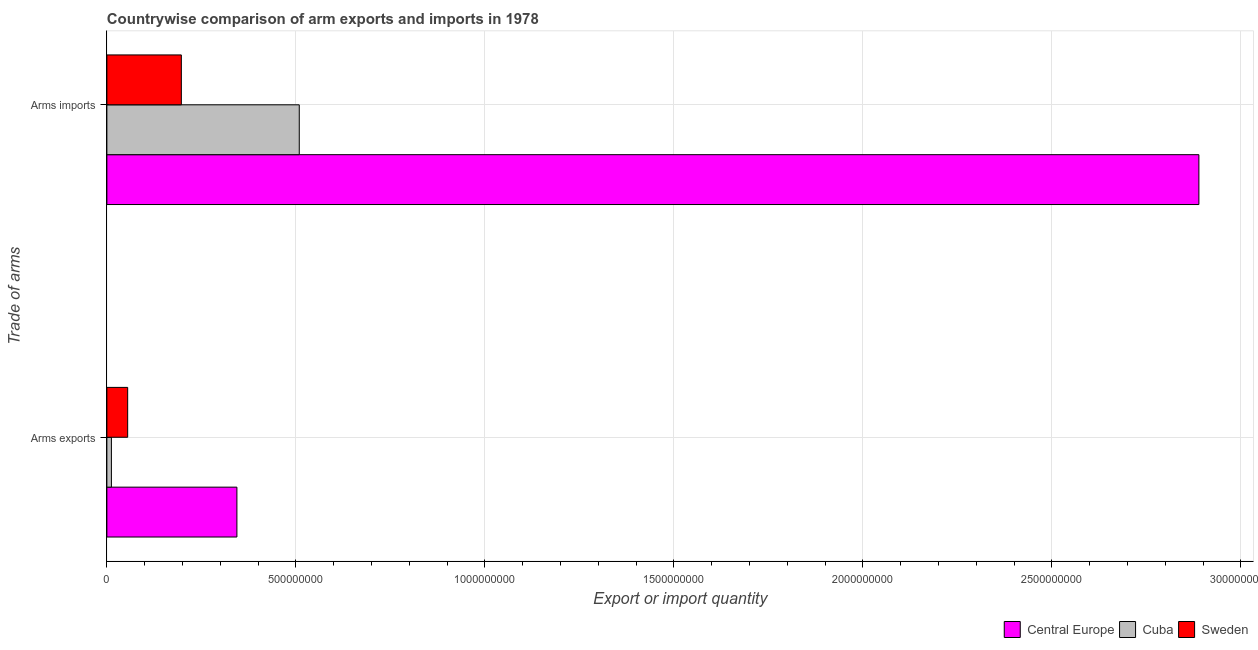How many bars are there on the 1st tick from the top?
Your answer should be compact. 3. What is the label of the 1st group of bars from the top?
Offer a very short reply. Arms imports. What is the arms imports in Cuba?
Your answer should be very brief. 5.09e+08. Across all countries, what is the maximum arms imports?
Your answer should be compact. 2.89e+09. Across all countries, what is the minimum arms exports?
Offer a terse response. 1.20e+07. In which country was the arms exports maximum?
Provide a short and direct response. Central Europe. What is the total arms exports in the graph?
Ensure brevity in your answer.  4.11e+08. What is the difference between the arms imports in Central Europe and that in Cuba?
Keep it short and to the point. 2.38e+09. What is the difference between the arms imports in Cuba and the arms exports in Central Europe?
Offer a very short reply. 1.65e+08. What is the average arms imports per country?
Give a very brief answer. 1.20e+09. What is the difference between the arms exports and arms imports in Sweden?
Give a very brief answer. -1.42e+08. In how many countries, is the arms exports greater than 100000000 ?
Your answer should be very brief. 1. What is the ratio of the arms imports in Sweden to that in Cuba?
Keep it short and to the point. 0.39. In how many countries, is the arms imports greater than the average arms imports taken over all countries?
Provide a succinct answer. 1. What does the 2nd bar from the top in Arms exports represents?
Make the answer very short. Cuba. What does the 2nd bar from the bottom in Arms exports represents?
Ensure brevity in your answer.  Cuba. How many bars are there?
Your answer should be compact. 6. Are all the bars in the graph horizontal?
Give a very brief answer. Yes. What is the difference between two consecutive major ticks on the X-axis?
Ensure brevity in your answer.  5.00e+08. Are the values on the major ticks of X-axis written in scientific E-notation?
Offer a terse response. No. Does the graph contain any zero values?
Your answer should be compact. No. Does the graph contain grids?
Make the answer very short. Yes. How are the legend labels stacked?
Give a very brief answer. Horizontal. What is the title of the graph?
Give a very brief answer. Countrywise comparison of arm exports and imports in 1978. Does "Guatemala" appear as one of the legend labels in the graph?
Give a very brief answer. No. What is the label or title of the X-axis?
Your response must be concise. Export or import quantity. What is the label or title of the Y-axis?
Your response must be concise. Trade of arms. What is the Export or import quantity of Central Europe in Arms exports?
Your response must be concise. 3.44e+08. What is the Export or import quantity in Cuba in Arms exports?
Offer a very short reply. 1.20e+07. What is the Export or import quantity of Sweden in Arms exports?
Offer a very short reply. 5.50e+07. What is the Export or import quantity of Central Europe in Arms imports?
Offer a terse response. 2.89e+09. What is the Export or import quantity of Cuba in Arms imports?
Your answer should be compact. 5.09e+08. What is the Export or import quantity of Sweden in Arms imports?
Make the answer very short. 1.97e+08. Across all Trade of arms, what is the maximum Export or import quantity of Central Europe?
Ensure brevity in your answer.  2.89e+09. Across all Trade of arms, what is the maximum Export or import quantity in Cuba?
Provide a short and direct response. 5.09e+08. Across all Trade of arms, what is the maximum Export or import quantity of Sweden?
Provide a short and direct response. 1.97e+08. Across all Trade of arms, what is the minimum Export or import quantity in Central Europe?
Provide a succinct answer. 3.44e+08. Across all Trade of arms, what is the minimum Export or import quantity of Sweden?
Your response must be concise. 5.50e+07. What is the total Export or import quantity of Central Europe in the graph?
Your response must be concise. 3.23e+09. What is the total Export or import quantity in Cuba in the graph?
Your response must be concise. 5.21e+08. What is the total Export or import quantity in Sweden in the graph?
Keep it short and to the point. 2.52e+08. What is the difference between the Export or import quantity of Central Europe in Arms exports and that in Arms imports?
Give a very brief answer. -2.54e+09. What is the difference between the Export or import quantity of Cuba in Arms exports and that in Arms imports?
Give a very brief answer. -4.97e+08. What is the difference between the Export or import quantity in Sweden in Arms exports and that in Arms imports?
Provide a succinct answer. -1.42e+08. What is the difference between the Export or import quantity in Central Europe in Arms exports and the Export or import quantity in Cuba in Arms imports?
Your answer should be compact. -1.65e+08. What is the difference between the Export or import quantity in Central Europe in Arms exports and the Export or import quantity in Sweden in Arms imports?
Your answer should be compact. 1.47e+08. What is the difference between the Export or import quantity of Cuba in Arms exports and the Export or import quantity of Sweden in Arms imports?
Your answer should be very brief. -1.85e+08. What is the average Export or import quantity of Central Europe per Trade of arms?
Keep it short and to the point. 1.62e+09. What is the average Export or import quantity in Cuba per Trade of arms?
Offer a very short reply. 2.60e+08. What is the average Export or import quantity in Sweden per Trade of arms?
Provide a short and direct response. 1.26e+08. What is the difference between the Export or import quantity in Central Europe and Export or import quantity in Cuba in Arms exports?
Keep it short and to the point. 3.32e+08. What is the difference between the Export or import quantity of Central Europe and Export or import quantity of Sweden in Arms exports?
Your answer should be compact. 2.89e+08. What is the difference between the Export or import quantity of Cuba and Export or import quantity of Sweden in Arms exports?
Keep it short and to the point. -4.30e+07. What is the difference between the Export or import quantity of Central Europe and Export or import quantity of Cuba in Arms imports?
Your answer should be compact. 2.38e+09. What is the difference between the Export or import quantity of Central Europe and Export or import quantity of Sweden in Arms imports?
Keep it short and to the point. 2.69e+09. What is the difference between the Export or import quantity of Cuba and Export or import quantity of Sweden in Arms imports?
Ensure brevity in your answer.  3.12e+08. What is the ratio of the Export or import quantity of Central Europe in Arms exports to that in Arms imports?
Make the answer very short. 0.12. What is the ratio of the Export or import quantity in Cuba in Arms exports to that in Arms imports?
Provide a short and direct response. 0.02. What is the ratio of the Export or import quantity of Sweden in Arms exports to that in Arms imports?
Provide a short and direct response. 0.28. What is the difference between the highest and the second highest Export or import quantity of Central Europe?
Offer a very short reply. 2.54e+09. What is the difference between the highest and the second highest Export or import quantity in Cuba?
Offer a terse response. 4.97e+08. What is the difference between the highest and the second highest Export or import quantity in Sweden?
Provide a succinct answer. 1.42e+08. What is the difference between the highest and the lowest Export or import quantity of Central Europe?
Provide a succinct answer. 2.54e+09. What is the difference between the highest and the lowest Export or import quantity in Cuba?
Offer a very short reply. 4.97e+08. What is the difference between the highest and the lowest Export or import quantity of Sweden?
Make the answer very short. 1.42e+08. 